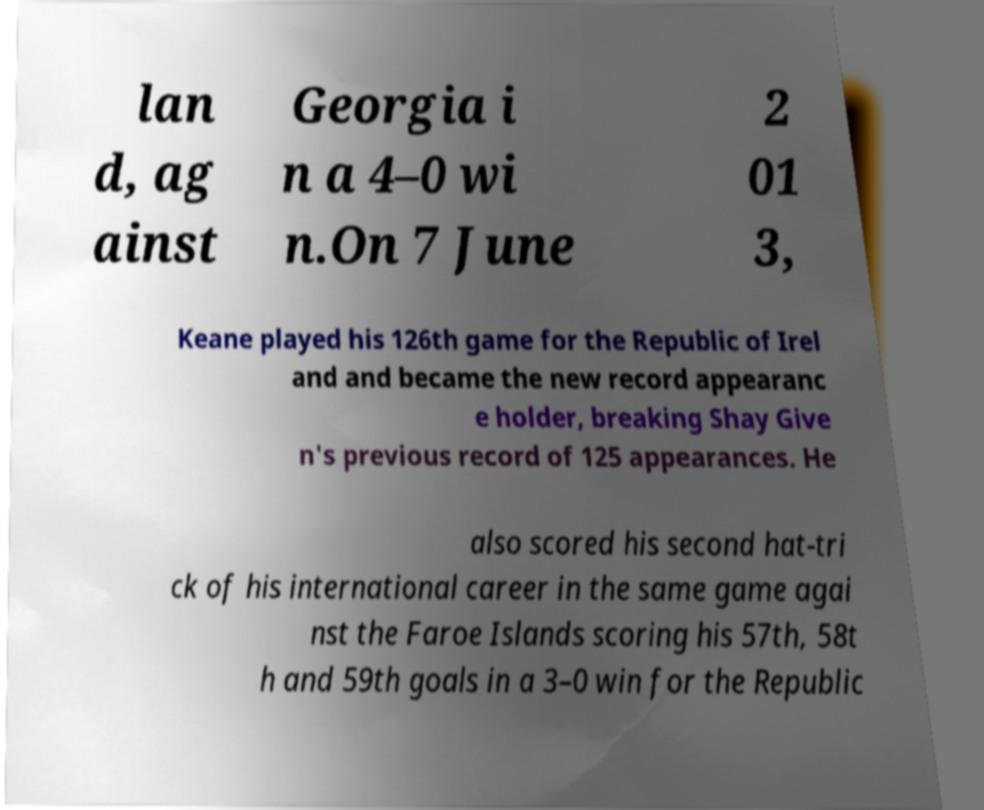Can you read and provide the text displayed in the image?This photo seems to have some interesting text. Can you extract and type it out for me? lan d, ag ainst Georgia i n a 4–0 wi n.On 7 June 2 01 3, Keane played his 126th game for the Republic of Irel and and became the new record appearanc e holder, breaking Shay Give n's previous record of 125 appearances. He also scored his second hat-tri ck of his international career in the same game agai nst the Faroe Islands scoring his 57th, 58t h and 59th goals in a 3–0 win for the Republic 